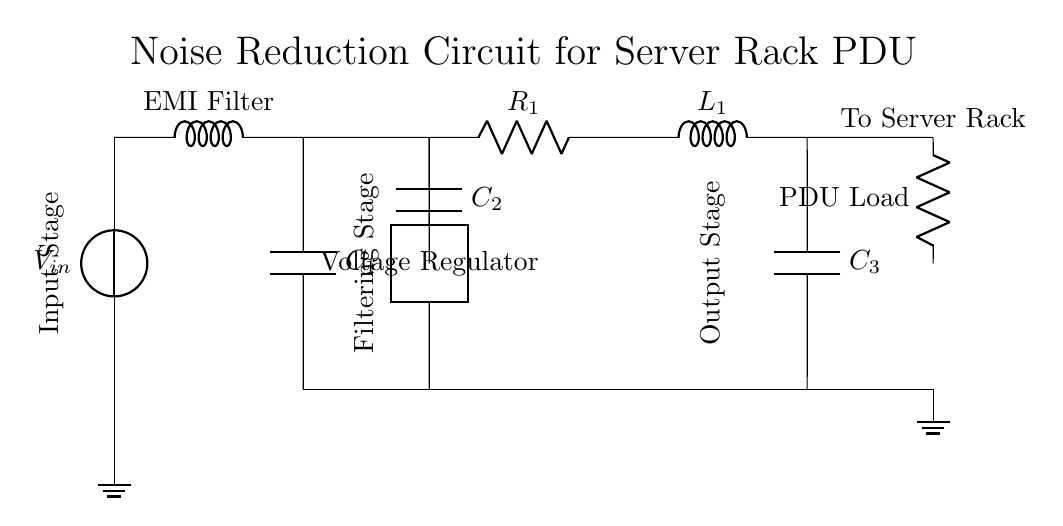What is the type of the first component? The first component in the circuit is a voltage source labeled as V in, which provides the input voltage for the circuit.
Answer: Voltage source What is the role of the EMI filter? The EMI filter is used to reduce electromagnetic interference from the power input to ensure clean power supply to the performance of the subsequent components.
Answer: Reducing interference How many capacitors are present in the circuit? There are three capacitors labeled C1, C2, and C3. Thus, the total count of capacitors is three in the circuit.
Answer: Three What is connected to the output stage? The output stage connects to an inductor labeled as L1 and a capacitor labeled as C3, which together help to smooth the output signal before reaching the load.
Answer: Inductor and capacitor Which component provides noise suppression? The capacitor labeled C2 serves the purpose of noise suppression to filter out any unwanted high-frequency noise that could affect the load.
Answer: C2 What load does the circuit serve? The circuit is designed to supply power to a device labeled as PDU Load, representing the load connected to the power distribution unit.
Answer: PDU Load What is the function of the voltage regulator? The voltage regulator regulates the output voltage, ensuring it is stable and within the required range while overcoming any fluctuations from the input.
Answer: Regulating output voltage 